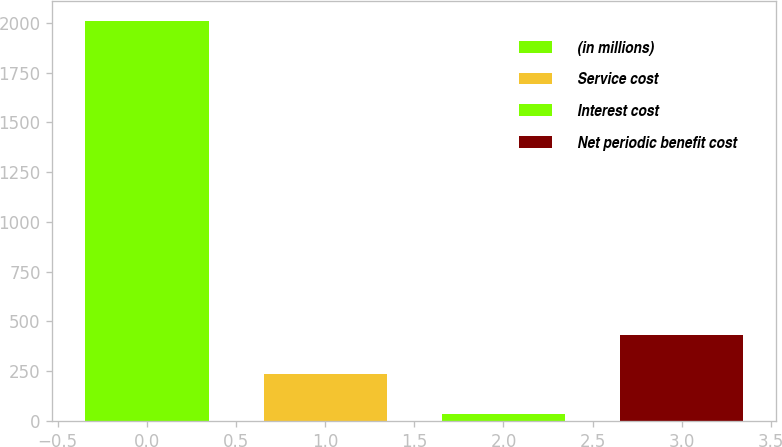<chart> <loc_0><loc_0><loc_500><loc_500><bar_chart><fcel>(in millions)<fcel>Service cost<fcel>Interest cost<fcel>Net periodic benefit cost<nl><fcel>2011<fcel>234.4<fcel>37<fcel>431.8<nl></chart> 